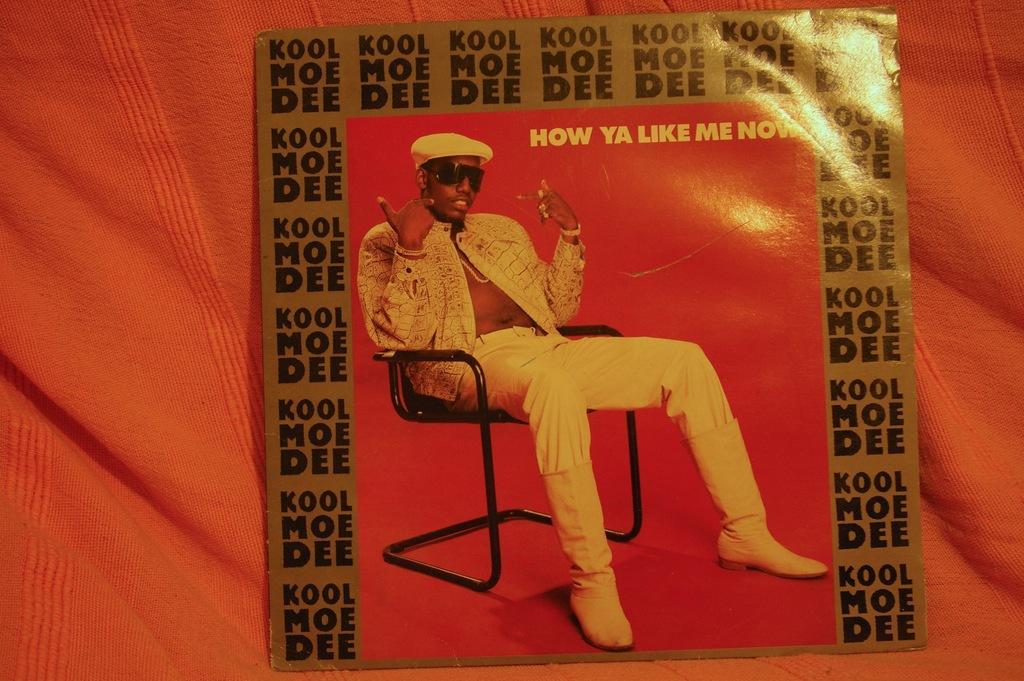Describe this image in one or two sentences. In this picture, we see a poster in which man in white blazer is sitting on chair. He is even wearing white cap and on the poster, we even see some text written on it and this poster is placed on orange color cloth. 